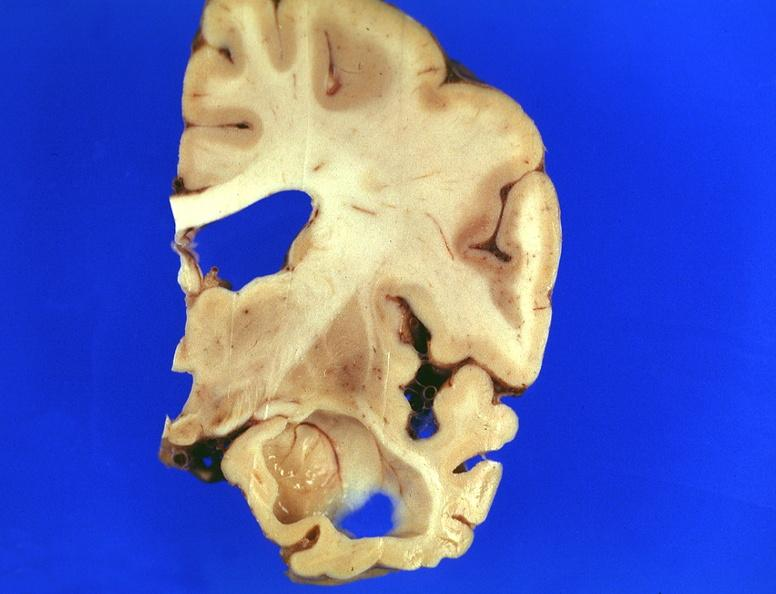what is present?
Answer the question using a single word or phrase. Nervous 